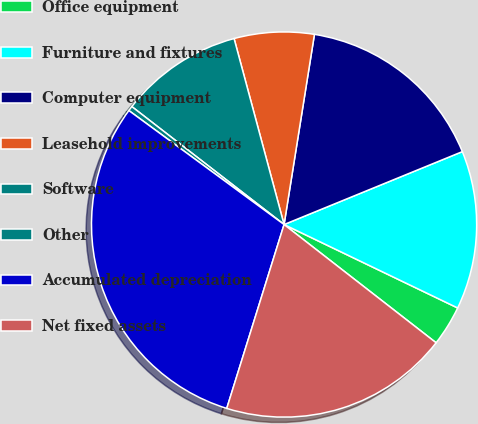Convert chart to OTSL. <chart><loc_0><loc_0><loc_500><loc_500><pie_chart><fcel>Office equipment<fcel>Furniture and fixtures<fcel>Computer equipment<fcel>Leasehold improvements<fcel>Software<fcel>Other<fcel>Accumulated depreciation<fcel>Net fixed assets<nl><fcel>3.39%<fcel>13.31%<fcel>16.3%<fcel>6.7%<fcel>10.33%<fcel>0.41%<fcel>30.27%<fcel>19.29%<nl></chart> 